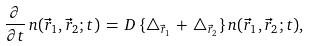Convert formula to latex. <formula><loc_0><loc_0><loc_500><loc_500>\frac { \partial } { \partial t } \, n ( \vec { r } _ { 1 } , \vec { r } _ { 2 } ; t ) \, = \, D \, \{ \triangle _ { \vec { r } _ { 1 } } \, + \, \triangle _ { \vec { r } _ { 2 } } \} \, n ( \vec { r } _ { 1 } , \vec { r } _ { 2 } ; t ) ,</formula> 